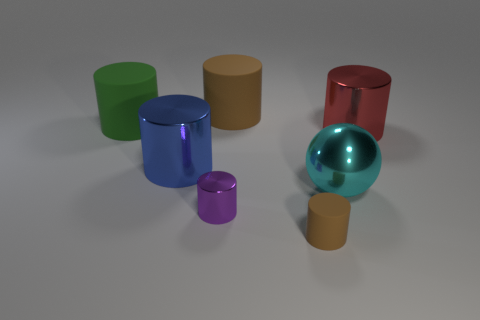Subtract all purple metallic cylinders. How many cylinders are left? 5 Subtract all red blocks. How many brown cylinders are left? 2 Subtract all green cylinders. How many cylinders are left? 5 Subtract 1 cylinders. How many cylinders are left? 5 Add 2 red metallic balls. How many objects exist? 9 Subtract all brown cylinders. Subtract all yellow blocks. How many cylinders are left? 4 Subtract all cylinders. How many objects are left? 1 Subtract 0 purple balls. How many objects are left? 7 Subtract all tiny red cubes. Subtract all large brown things. How many objects are left? 6 Add 3 tiny purple shiny objects. How many tiny purple shiny objects are left? 4 